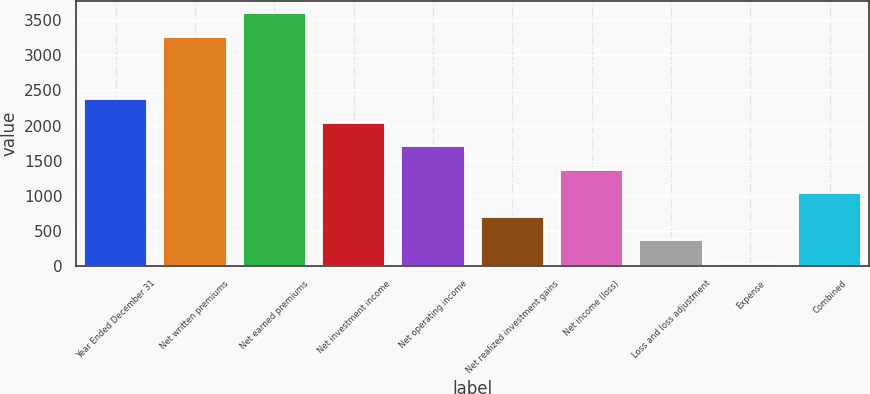Convert chart to OTSL. <chart><loc_0><loc_0><loc_500><loc_500><bar_chart><fcel>Year Ended December 31<fcel>Net written premiums<fcel>Net earned premiums<fcel>Net investment income<fcel>Net operating income<fcel>Net realized investment gains<fcel>Net income (loss)<fcel>Loss and loss adjustment<fcel>Expense<fcel>Combined<nl><fcel>2375.05<fcel>3267<fcel>3601.65<fcel>2040.4<fcel>1705.75<fcel>701.8<fcel>1371.1<fcel>367.15<fcel>32.5<fcel>1036.45<nl></chart> 